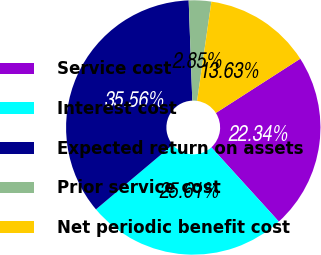Convert chart. <chart><loc_0><loc_0><loc_500><loc_500><pie_chart><fcel>Service cost<fcel>Interest cost<fcel>Expected return on assets<fcel>Prior service cost<fcel>Net periodic benefit cost<nl><fcel>22.34%<fcel>25.61%<fcel>35.56%<fcel>2.85%<fcel>13.63%<nl></chart> 